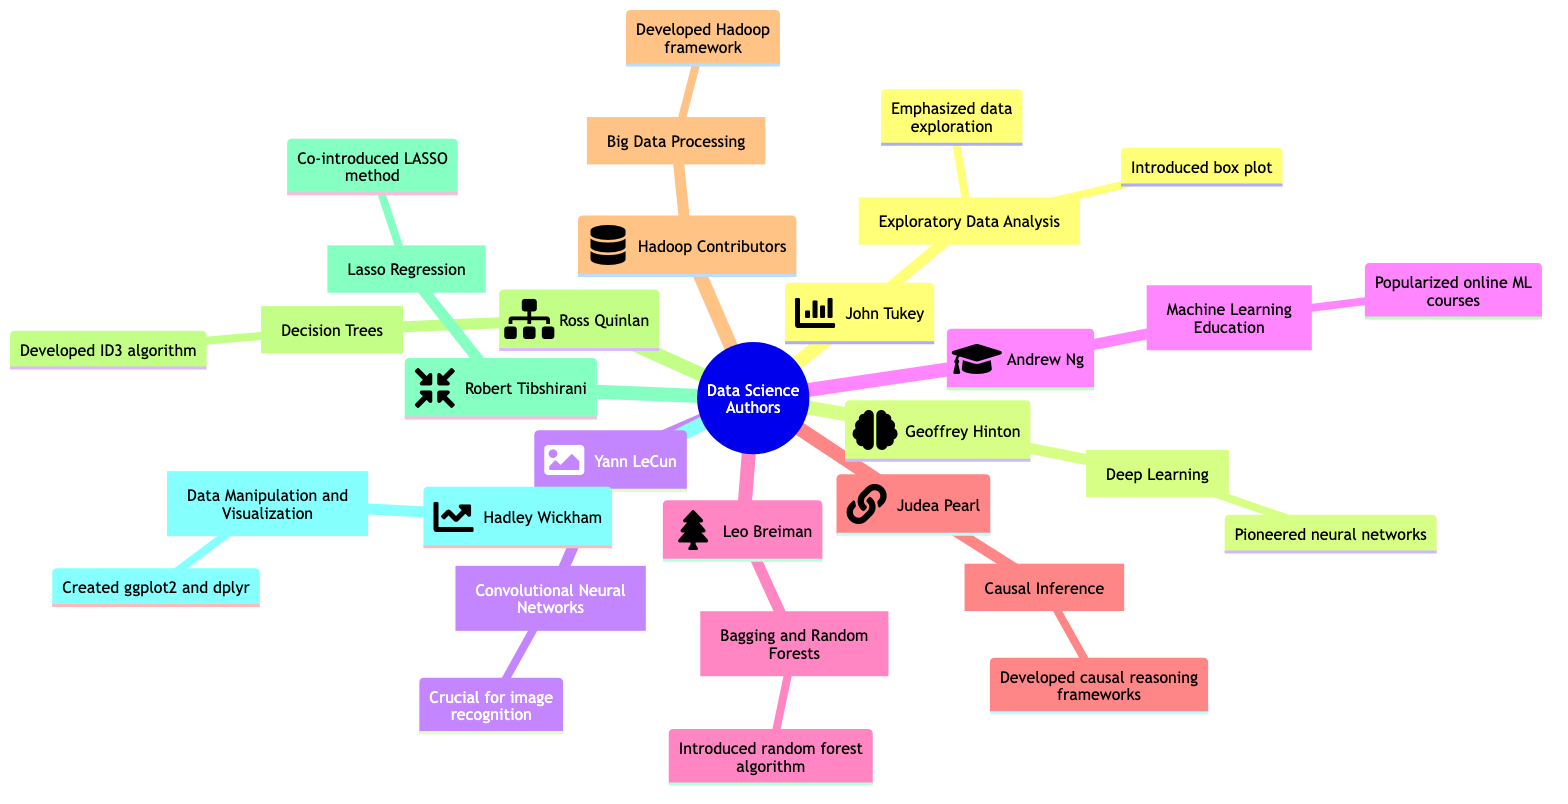What is the key work of John Tukey? In the diagram, the key work associated with John Tukey is clearly labeled as "Exploratory Data Analysis". This is located under his name.
Answer: Exploratory Data Analysis How many major authors are listed in the mind map? To find the number of major authors, you can count the individual nodes under the main topic "Key Contributions of Major Authors in Data Science". There are ten authors listed.
Answer: 10 Which author is associated with convolutional neural networks? The diagram states that Yann LeCun is the author associated with "Convolutional Neural Networks". This is highlighted directly under his name.
Answer: Yann LeCun What contribution did Andrew Ng make to machine learning? The mind map indicates that Andrew Ng's major contribution is related to "Popularized machine learning through online courses". This information is specified in the section dedicated to him.
Answer: Popularized machine learning through online courses What do both John Tukey and Leo Breiman have in common regarding data analysis? Analyzing the contributions of both authors, they both have introduced methods that enhance data analysis techniques. John Tukey introduced the box plot, while Leo Breiman introduced bagging and random forests. Both aim to improve how data is understood and utilized.
Answer: Introduced methods enhancing data analysis Which author's work focuses on causal reasoning? In the mind map, it is shown that Judea Pearl's key work is on "Causal Inference", which directly relates to causal reasoning frameworks in data science.
Answer: Judea Pearl What significant algorithm did Ross Quinlan develop? The diagram specifies that Ross Quinlan developed the "ID3 algorithm". This information is included in his section under the title "Decision Trees".
Answer: ID3 algorithm Which author is known for creating the ggplot2 package? The mind map states that Hadley Wickham is credited with creating "ggplot2", along with other R packages aimed at data manipulation and visualization. This is positioned in his part of the diagram.
Answer: Hadley Wickham 